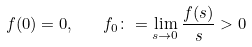Convert formula to latex. <formula><loc_0><loc_0><loc_500><loc_500>f ( 0 ) = 0 , \quad f _ { 0 } \colon = \lim _ { s \to 0 } \frac { f ( s ) } { s } > 0</formula> 